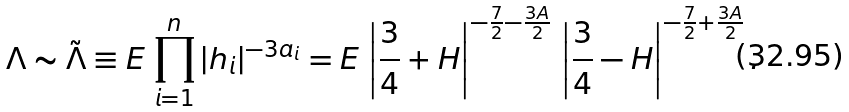Convert formula to latex. <formula><loc_0><loc_0><loc_500><loc_500>\Lambda \sim \tilde { \Lambda } \equiv E \, \prod _ { i = 1 } ^ { n } | h _ { i } | ^ { - 3 a _ { i } } = E \, \left | \frac { 3 } { 4 } + H \right | ^ { - \frac { 7 } { 2 } - \frac { 3 A } { 2 } } \, \left | \frac { 3 } { 4 } - H \right | ^ { - \frac { 7 } { 2 } + \frac { 3 A } { 2 } } .</formula> 